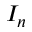<formula> <loc_0><loc_0><loc_500><loc_500>I _ { n }</formula> 